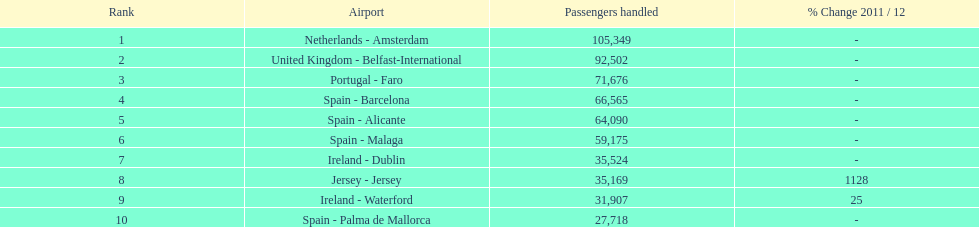How many airports in spain are among the 10 busiest routes to and from london southend airport in 2012? 4. Help me parse the entirety of this table. {'header': ['Rank', 'Airport', 'Passengers handled', '% Change 2011 / 12'], 'rows': [['1', 'Netherlands - Amsterdam', '105,349', '-'], ['2', 'United Kingdom - Belfast-International', '92,502', '-'], ['3', 'Portugal - Faro', '71,676', '-'], ['4', 'Spain - Barcelona', '66,565', '-'], ['5', 'Spain - Alicante', '64,090', '-'], ['6', 'Spain - Malaga', '59,175', '-'], ['7', 'Ireland - Dublin', '35,524', '-'], ['8', 'Jersey - Jersey', '35,169', '1128'], ['9', 'Ireland - Waterford', '31,907', '25'], ['10', 'Spain - Palma de Mallorca', '27,718', '-']]} 